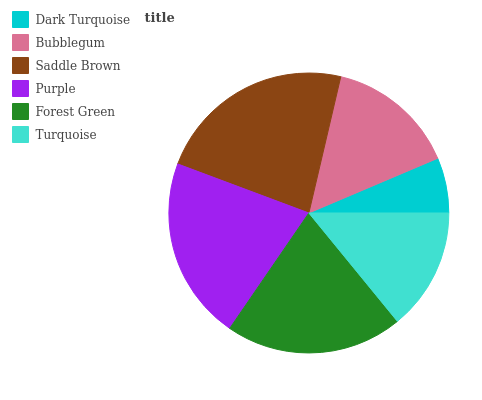Is Dark Turquoise the minimum?
Answer yes or no. Yes. Is Saddle Brown the maximum?
Answer yes or no. Yes. Is Bubblegum the minimum?
Answer yes or no. No. Is Bubblegum the maximum?
Answer yes or no. No. Is Bubblegum greater than Dark Turquoise?
Answer yes or no. Yes. Is Dark Turquoise less than Bubblegum?
Answer yes or no. Yes. Is Dark Turquoise greater than Bubblegum?
Answer yes or no. No. Is Bubblegum less than Dark Turquoise?
Answer yes or no. No. Is Forest Green the high median?
Answer yes or no. Yes. Is Bubblegum the low median?
Answer yes or no. Yes. Is Purple the high median?
Answer yes or no. No. Is Saddle Brown the low median?
Answer yes or no. No. 